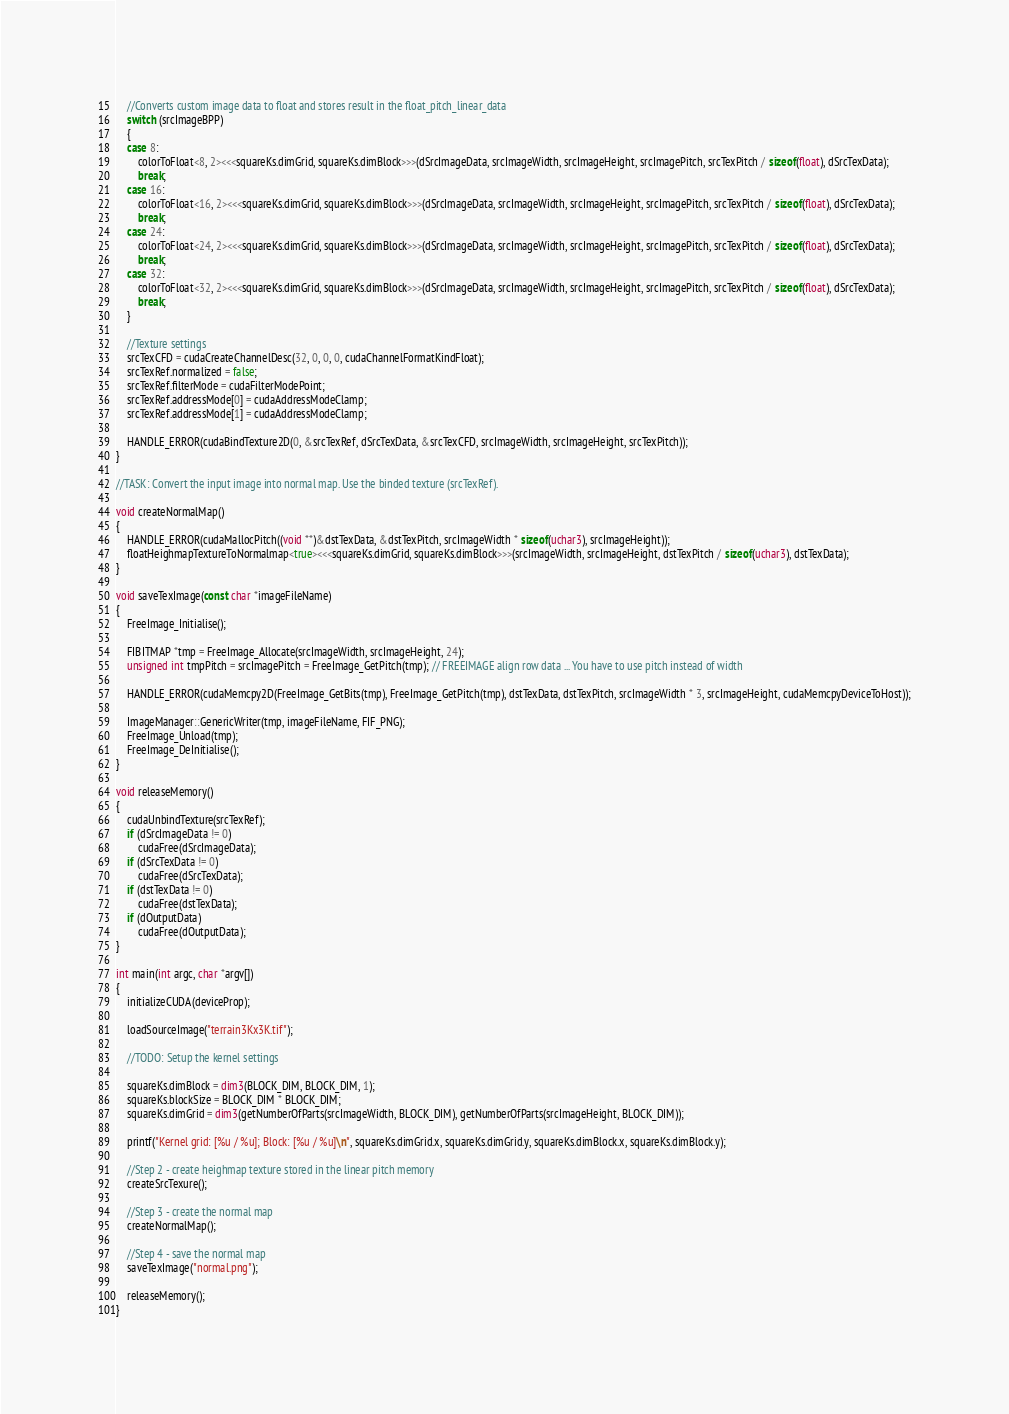Convert code to text. <code><loc_0><loc_0><loc_500><loc_500><_Cuda_>	//Converts custom image data to float and stores result in the float_pitch_linear_data
	switch (srcImageBPP)
	{
	case 8:
		colorToFloat<8, 2><<<squareKs.dimGrid, squareKs.dimBlock>>>(dSrcImageData, srcImageWidth, srcImageHeight, srcImagePitch, srcTexPitch / sizeof(float), dSrcTexData);
		break;
	case 16:
		colorToFloat<16, 2><<<squareKs.dimGrid, squareKs.dimBlock>>>(dSrcImageData, srcImageWidth, srcImageHeight, srcImagePitch, srcTexPitch / sizeof(float), dSrcTexData);
		break;
	case 24:
		colorToFloat<24, 2><<<squareKs.dimGrid, squareKs.dimBlock>>>(dSrcImageData, srcImageWidth, srcImageHeight, srcImagePitch, srcTexPitch / sizeof(float), dSrcTexData);
		break;
	case 32:
		colorToFloat<32, 2><<<squareKs.dimGrid, squareKs.dimBlock>>>(dSrcImageData, srcImageWidth, srcImageHeight, srcImagePitch, srcTexPitch / sizeof(float), dSrcTexData);
		break;
	}

	//Texture settings
	srcTexCFD = cudaCreateChannelDesc(32, 0, 0, 0, cudaChannelFormatKindFloat);
	srcTexRef.normalized = false;
	srcTexRef.filterMode = cudaFilterModePoint;
	srcTexRef.addressMode[0] = cudaAddressModeClamp;
	srcTexRef.addressMode[1] = cudaAddressModeClamp;

	HANDLE_ERROR(cudaBindTexture2D(0, &srcTexRef, dSrcTexData, &srcTexCFD, srcImageWidth, srcImageHeight, srcTexPitch));
}

//TASK:	Convert the input image into normal map. Use the binded texture (srcTexRef).

void createNormalMap()
{
	HANDLE_ERROR(cudaMallocPitch((void **)&dstTexData, &dstTexPitch, srcImageWidth * sizeof(uchar3), srcImageHeight));
	floatHeighmapTextureToNormalmap<true><<<squareKs.dimGrid, squareKs.dimBlock>>>(srcImageWidth, srcImageHeight, dstTexPitch / sizeof(uchar3), dstTexData);
}

void saveTexImage(const char *imageFileName)
{
	FreeImage_Initialise();

	FIBITMAP *tmp = FreeImage_Allocate(srcImageWidth, srcImageHeight, 24);
	unsigned int tmpPitch = srcImagePitch = FreeImage_GetPitch(tmp); // FREEIMAGE align row data ... You have to use pitch instead of width

	HANDLE_ERROR(cudaMemcpy2D(FreeImage_GetBits(tmp), FreeImage_GetPitch(tmp), dstTexData, dstTexPitch, srcImageWidth * 3, srcImageHeight, cudaMemcpyDeviceToHost));

	ImageManager::GenericWriter(tmp, imageFileName, FIF_PNG);
	FreeImage_Unload(tmp);
	FreeImage_DeInitialise();
}

void releaseMemory()
{
	cudaUnbindTexture(srcTexRef);
	if (dSrcImageData != 0)
		cudaFree(dSrcImageData);
	if (dSrcTexData != 0)
		cudaFree(dSrcTexData);
	if (dstTexData != 0)
		cudaFree(dstTexData);
	if (dOutputData)
		cudaFree(dOutputData);
}

int main(int argc, char *argv[])
{
	initializeCUDA(deviceProp);

	loadSourceImage("terrain3Kx3K.tif");

	//TODO: Setup the kernel settings

	squareKs.dimBlock = dim3(BLOCK_DIM, BLOCK_DIM, 1);
	squareKs.blockSize = BLOCK_DIM * BLOCK_DIM;
	squareKs.dimGrid = dim3(getNumberOfParts(srcImageWidth, BLOCK_DIM), getNumberOfParts(srcImageHeight, BLOCK_DIM));

	printf("Kernel grid: [%u / %u]; Block: [%u / %u]\n", squareKs.dimGrid.x, squareKs.dimGrid.y, squareKs.dimBlock.x, squareKs.dimBlock.y);

	//Step 2 - create heighmap texture stored in the linear pitch memory
	createSrcTexure();

	//Step 3 - create the normal map
	createNormalMap();

	//Step 4 - save the normal map
	saveTexImage("normal.png");

	releaseMemory();
}
</code> 